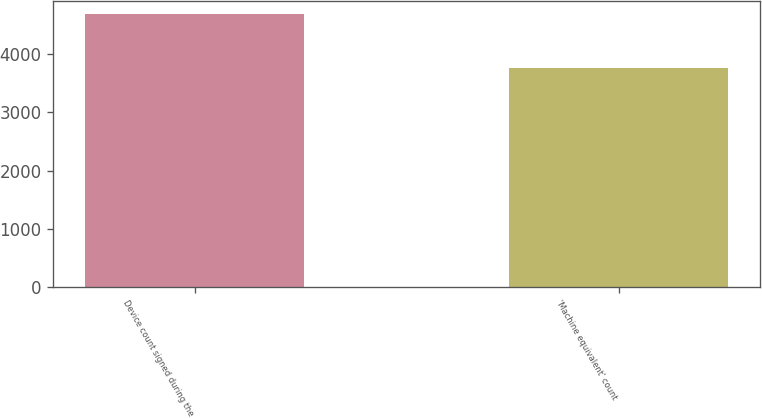Convert chart. <chart><loc_0><loc_0><loc_500><loc_500><bar_chart><fcel>Device count signed during the<fcel>'Machine equivalent' count<nl><fcel>4689<fcel>3769<nl></chart> 